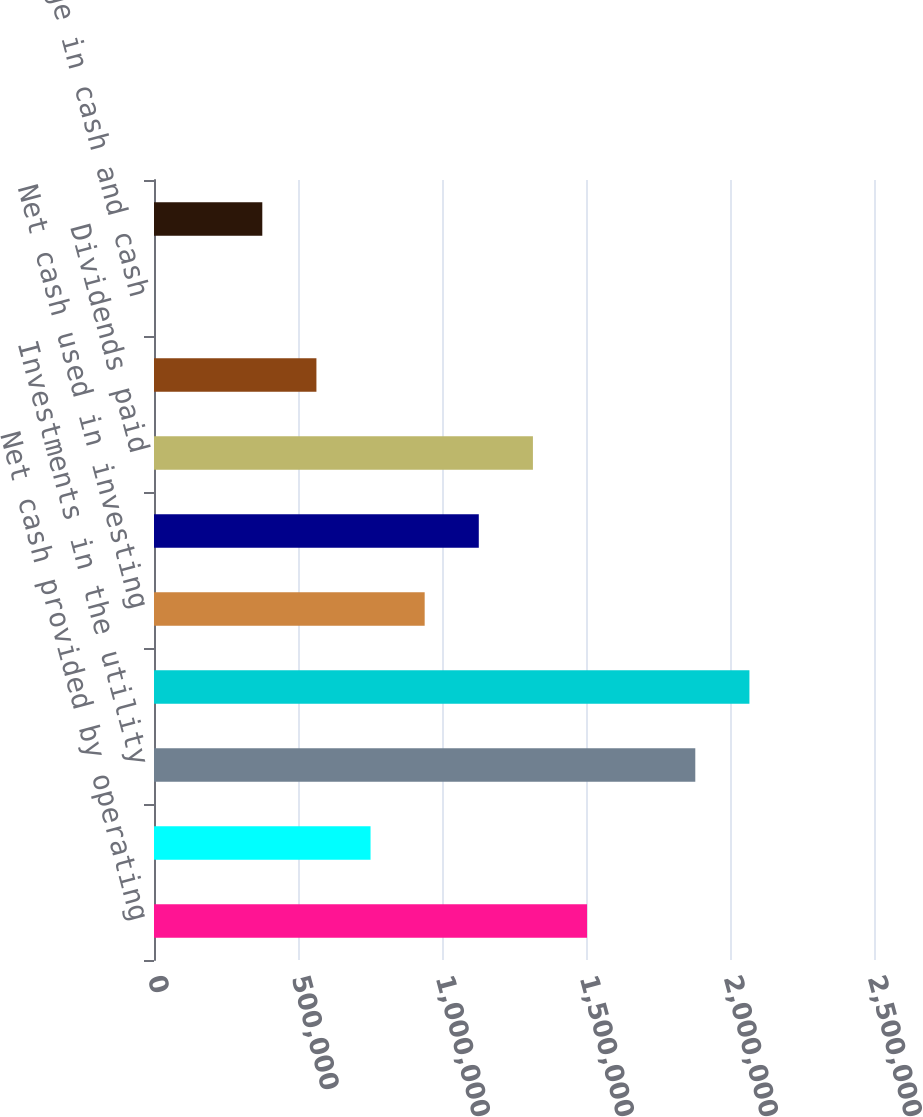<chart> <loc_0><loc_0><loc_500><loc_500><bar_chart><fcel>Net cash provided by operating<fcel>Capital contributions to<fcel>Investments in the utility<fcel>Return of investments in the<fcel>Net cash used in investing<fcel>Proceeds from (repayment of)<fcel>Dividends paid<fcel>Net cash provided by (used in)<fcel>Net change in cash and cash<fcel>Cash and cash equivalents at<nl><fcel>1.50363e+06<fcel>751900<fcel>1.8795e+06<fcel>2.06743e+06<fcel>939833<fcel>1.12777e+06<fcel>1.3157e+06<fcel>563966<fcel>166<fcel>376033<nl></chart> 